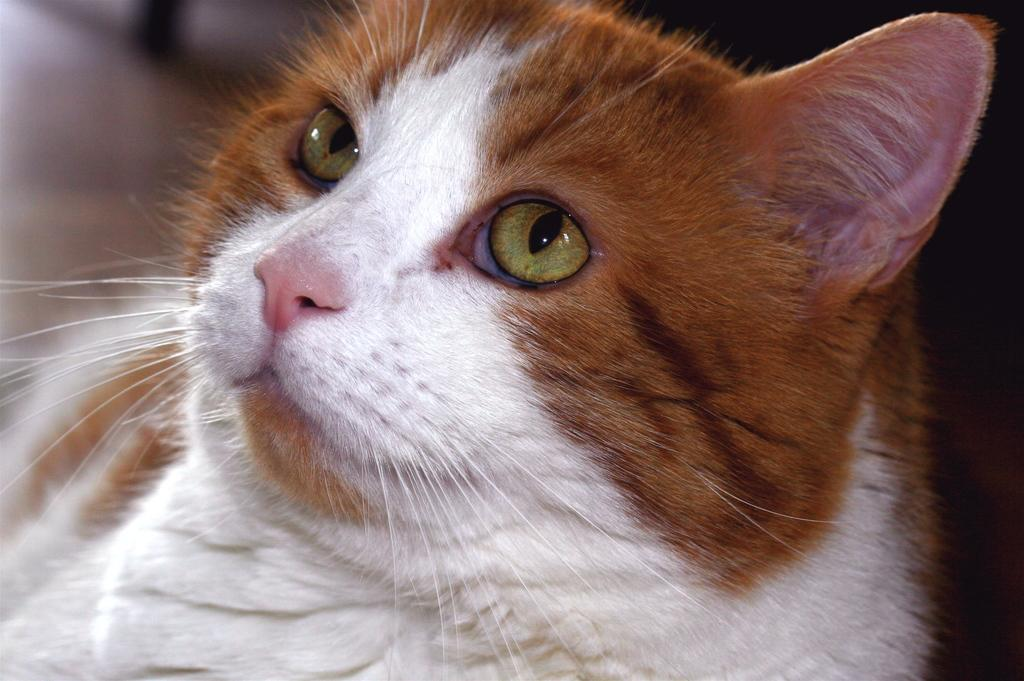What type of animal is in the image? There is a cat in the image. Can you describe the color of the cat? The cat has a brown and white color. How would you describe the background of the image? The background of the image is blurry. What type of stocking is the robin wearing in the image? There is no robin or stocking present in the image; it features a cat with a brown and white color. How does the cat blow out the candles on the cake in the image? There is no cake or candles present in the image; it only features a cat with a brown and white color. 